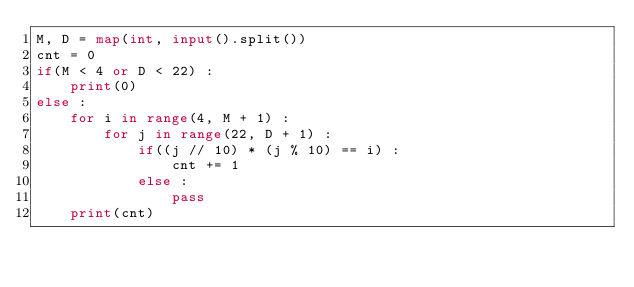Convert code to text. <code><loc_0><loc_0><loc_500><loc_500><_Python_>M, D = map(int, input().split())
cnt = 0
if(M < 4 or D < 22) :
    print(0)
else :
    for i in range(4, M + 1) :
        for j in range(22, D + 1) :
            if((j // 10) * (j % 10) == i) :
                cnt += 1
            else :
                pass
    print(cnt)</code> 